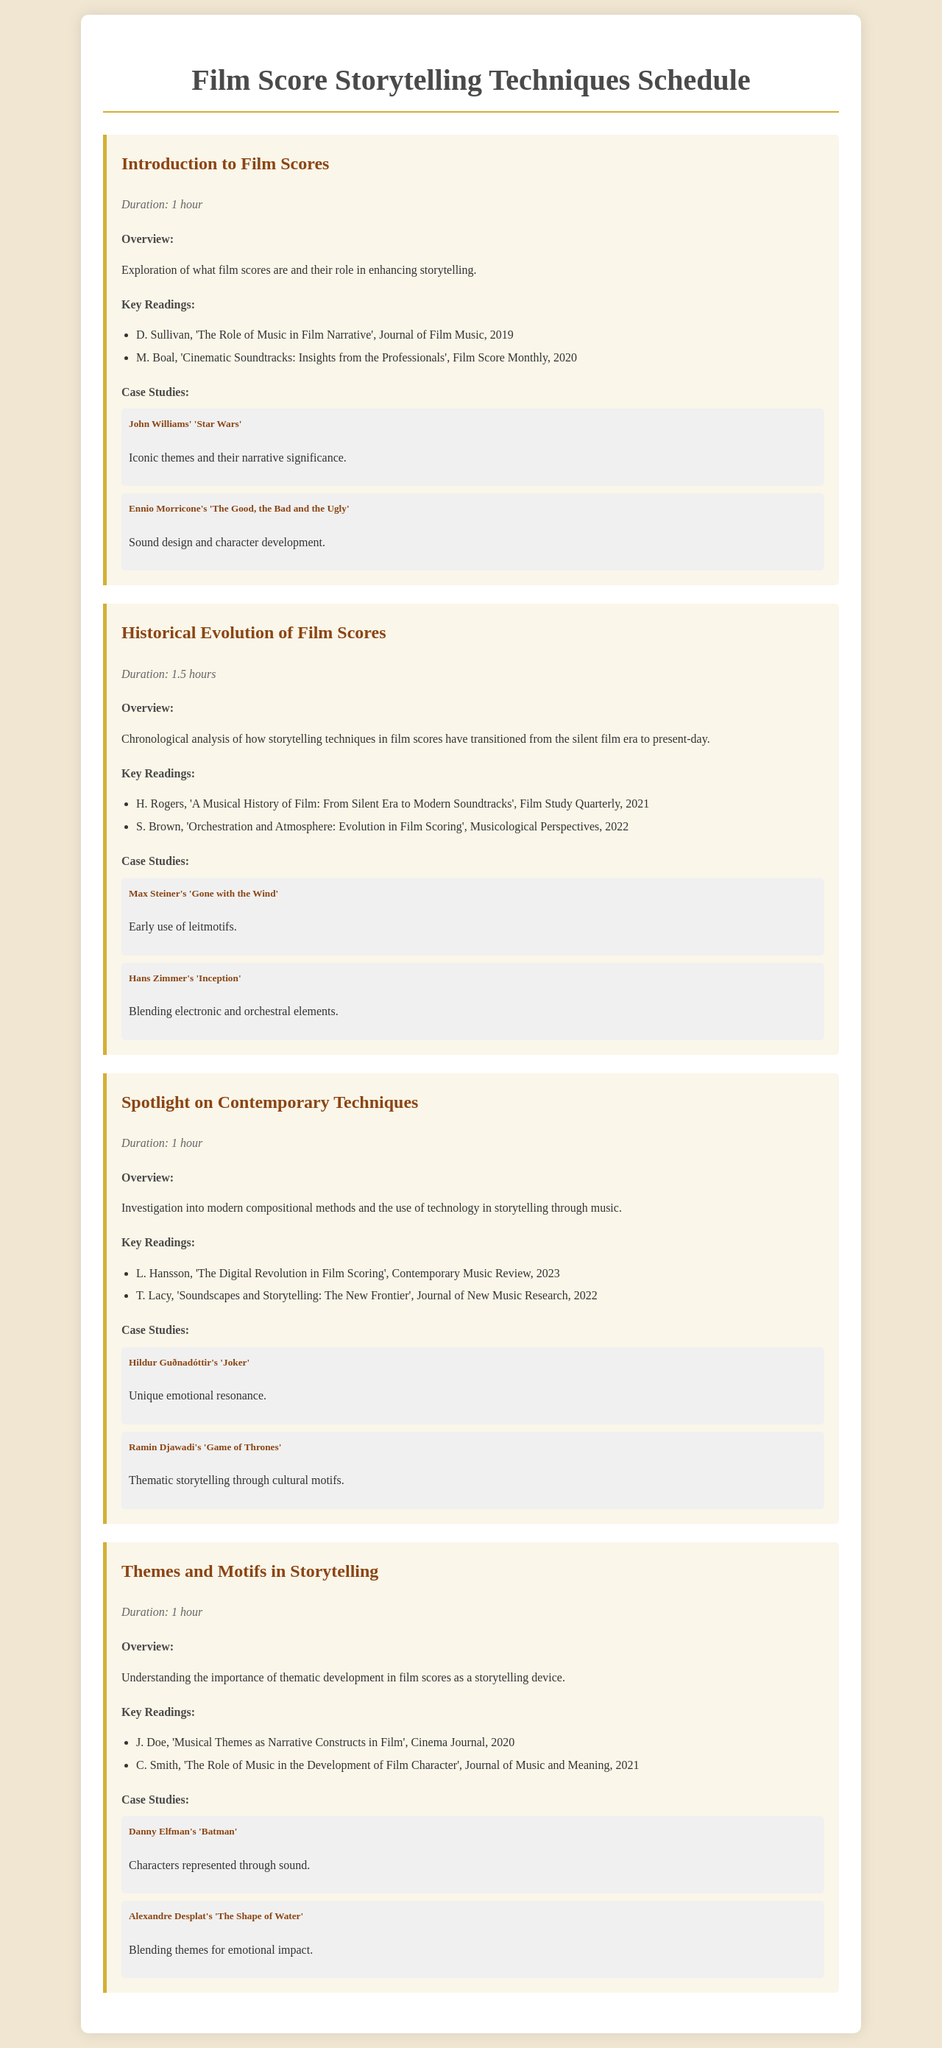What is the duration of the "Introduction to Film Scores" session? The duration is explicitly stated under the session title and is "1 hour".
Answer: 1 hour Who composed the score for "Inception"? The document provides the name of the composer linked to the case study, which is "Hans Zimmer".
Answer: Hans Zimmer What is the key reading listed for the "Themes and Motifs in Storytelling" session? The document offers specific readings, and one of them is "J. Doe, 'Musical Themes as Narrative Constructs in Film'".
Answer: J. Doe, 'Musical Themes as Narrative Constructs in Film' Which film score is associated with Hildur Guðnadóttir? The document mentions this in the case studies, specifying it as "Joker".
Answer: Joker What storytelling technique was early used in "Gone with the Wind"? The document points out this technique in the case study, described as "Early use of leitmotifs".
Answer: Early use of leitmotifs How long is the session on "Spotlight on Contemporary Techniques"? The session's duration is provided, which is "1 hour".
Answer: 1 hour Which article discusses the digital revolution in film scoring? The key reading provided for the session mentions "L. Hansson, 'The Digital Revolution in Film Scoring'".
Answer: L. Hansson, 'The Digital Revolution in Film Scoring' What is the thematic focus of Alexandre Desplat's "The Shape of Water"? The document describes this focus in the case study as "Blending themes for emotional impact".
Answer: Blending themes for emotional impact 